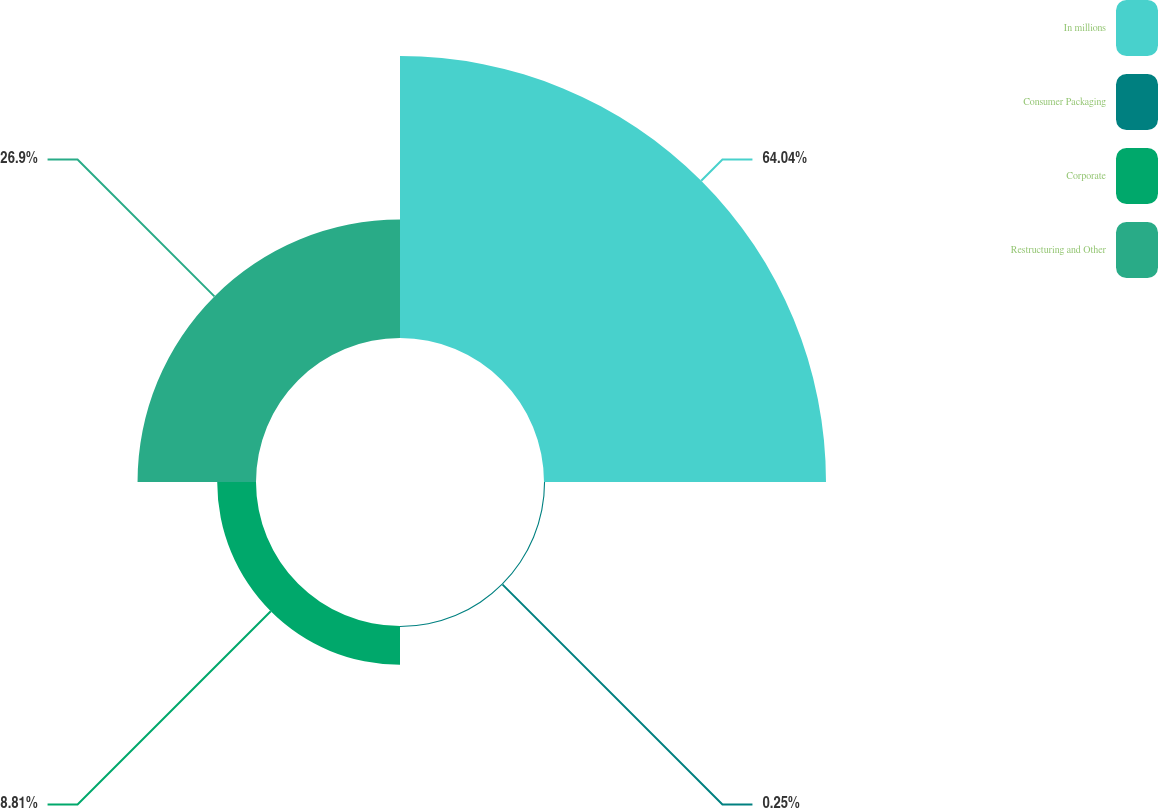<chart> <loc_0><loc_0><loc_500><loc_500><pie_chart><fcel>In millions<fcel>Consumer Packaging<fcel>Corporate<fcel>Restructuring and Other<nl><fcel>64.04%<fcel>0.25%<fcel>8.81%<fcel>26.9%<nl></chart> 